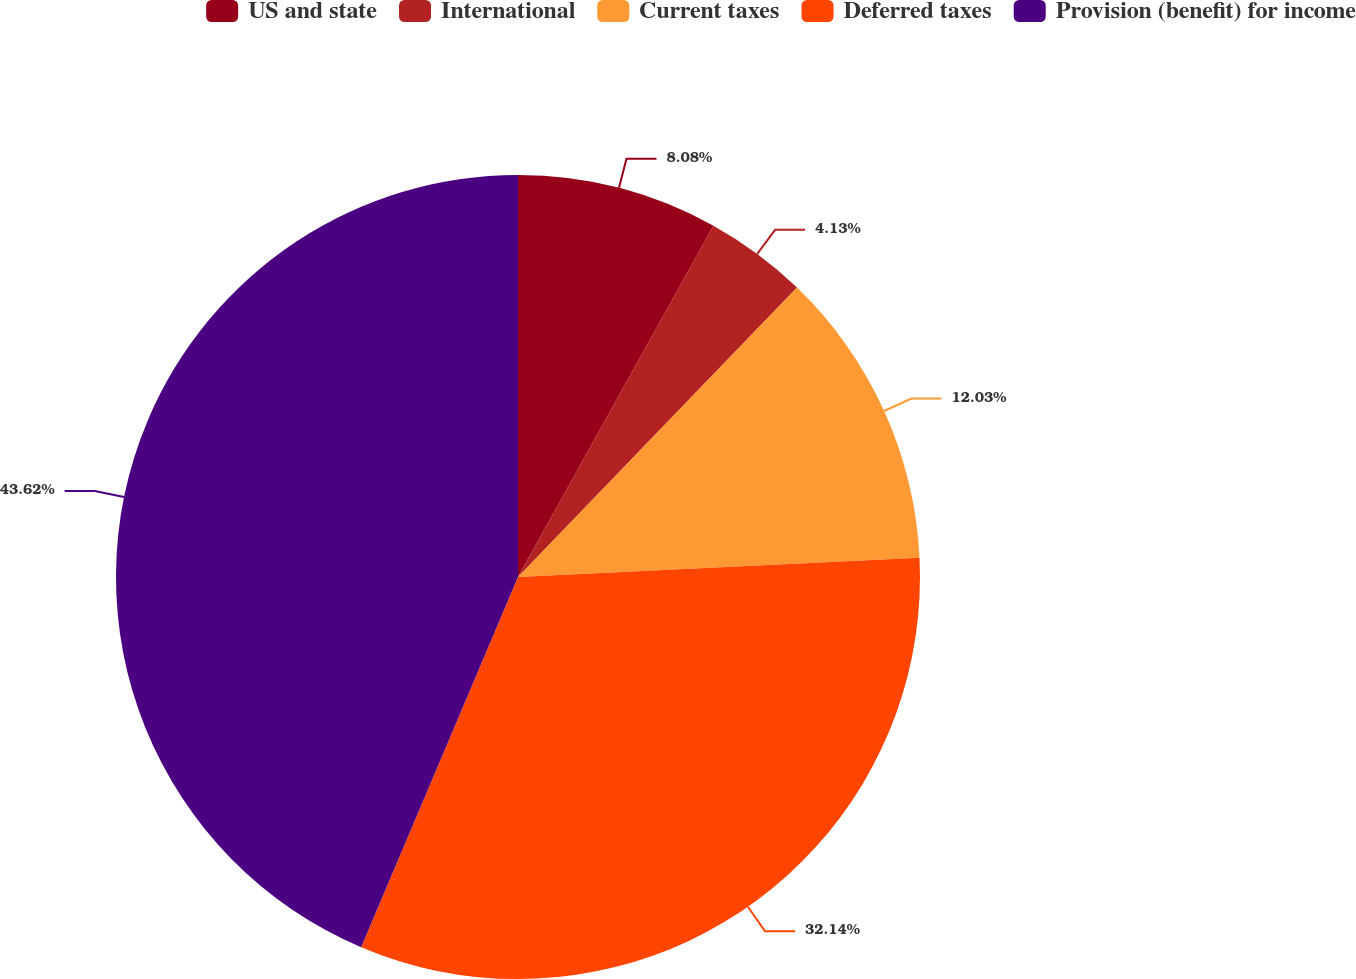Convert chart to OTSL. <chart><loc_0><loc_0><loc_500><loc_500><pie_chart><fcel>US and state<fcel>International<fcel>Current taxes<fcel>Deferred taxes<fcel>Provision (benefit) for income<nl><fcel>8.08%<fcel>4.13%<fcel>12.03%<fcel>32.14%<fcel>43.62%<nl></chart> 